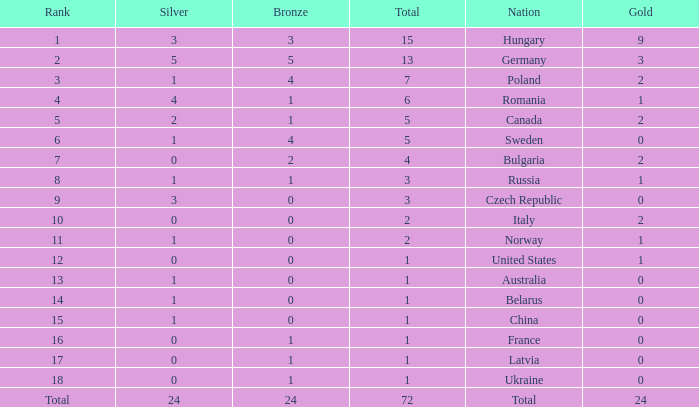What nation has 0 as the silver, 1 as the bronze, with 18 as the rank? Ukraine. 